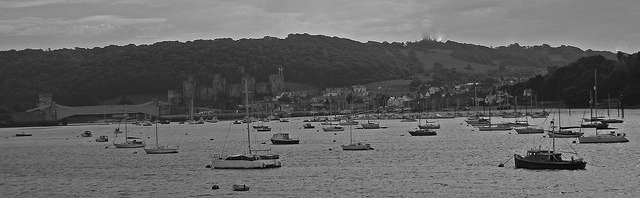Describe the objects in this image and their specific colors. I can see boat in gray, black, darkgray, and lightgray tones, boat in gray, black, darkgray, and lightgray tones, boat in black and gray tones, boat in gray and black tones, and boat in gray, black, and darkgray tones in this image. 